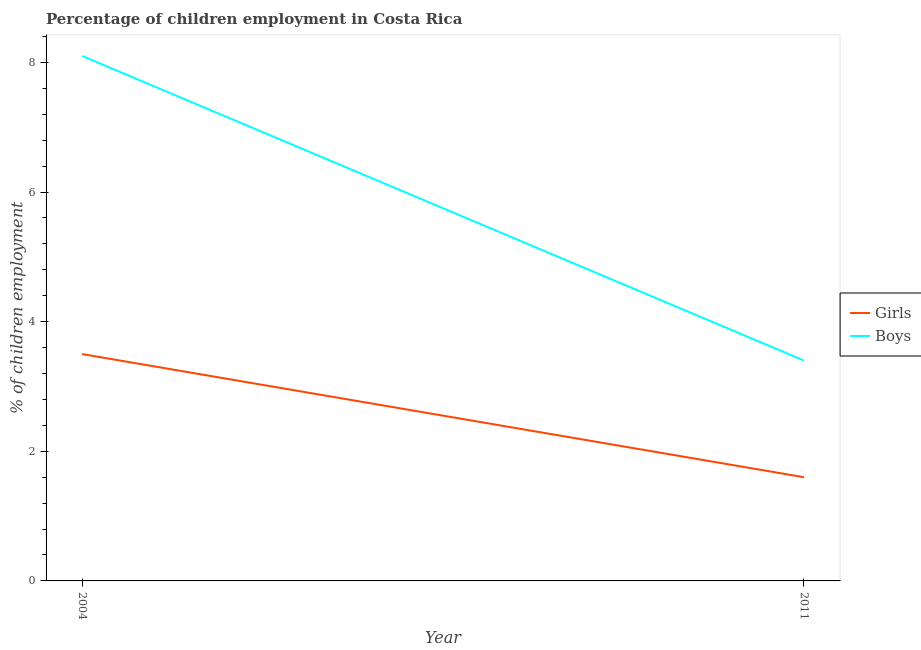How many different coloured lines are there?
Ensure brevity in your answer.  2. Does the line corresponding to percentage of employed girls intersect with the line corresponding to percentage of employed boys?
Your response must be concise. No. What is the percentage of employed boys in 2004?
Keep it short and to the point. 8.1. Across all years, what is the maximum percentage of employed girls?
Keep it short and to the point. 3.5. Across all years, what is the minimum percentage of employed boys?
Ensure brevity in your answer.  3.4. What is the difference between the percentage of employed boys in 2011 and the percentage of employed girls in 2004?
Provide a succinct answer. -0.1. What is the average percentage of employed girls per year?
Make the answer very short. 2.55. In the year 2004, what is the difference between the percentage of employed girls and percentage of employed boys?
Give a very brief answer. -4.6. What is the ratio of the percentage of employed boys in 2004 to that in 2011?
Make the answer very short. 2.38. Is the percentage of employed boys in 2004 less than that in 2011?
Offer a very short reply. No. In how many years, is the percentage of employed boys greater than the average percentage of employed boys taken over all years?
Keep it short and to the point. 1. Does the percentage of employed boys monotonically increase over the years?
Make the answer very short. No. Is the percentage of employed girls strictly greater than the percentage of employed boys over the years?
Offer a very short reply. No. Are the values on the major ticks of Y-axis written in scientific E-notation?
Make the answer very short. No. Does the graph contain grids?
Provide a succinct answer. No. Where does the legend appear in the graph?
Provide a succinct answer. Center right. How many legend labels are there?
Your answer should be compact. 2. What is the title of the graph?
Make the answer very short. Percentage of children employment in Costa Rica. What is the label or title of the X-axis?
Ensure brevity in your answer.  Year. What is the label or title of the Y-axis?
Make the answer very short. % of children employment. What is the % of children employment in Girls in 2004?
Your response must be concise. 3.5. What is the % of children employment in Girls in 2011?
Your response must be concise. 1.6. What is the % of children employment in Boys in 2011?
Offer a terse response. 3.4. Across all years, what is the maximum % of children employment in Boys?
Your answer should be compact. 8.1. Across all years, what is the minimum % of children employment in Boys?
Offer a very short reply. 3.4. What is the total % of children employment of Boys in the graph?
Offer a terse response. 11.5. What is the difference between the % of children employment of Girls in 2004 and that in 2011?
Provide a short and direct response. 1.9. What is the average % of children employment in Girls per year?
Keep it short and to the point. 2.55. What is the average % of children employment in Boys per year?
Offer a very short reply. 5.75. In the year 2011, what is the difference between the % of children employment of Girls and % of children employment of Boys?
Offer a very short reply. -1.8. What is the ratio of the % of children employment of Girls in 2004 to that in 2011?
Offer a very short reply. 2.19. What is the ratio of the % of children employment of Boys in 2004 to that in 2011?
Give a very brief answer. 2.38. What is the difference between the highest and the second highest % of children employment of Girls?
Ensure brevity in your answer.  1.9. What is the difference between the highest and the second highest % of children employment in Boys?
Ensure brevity in your answer.  4.7. What is the difference between the highest and the lowest % of children employment in Girls?
Make the answer very short. 1.9. 